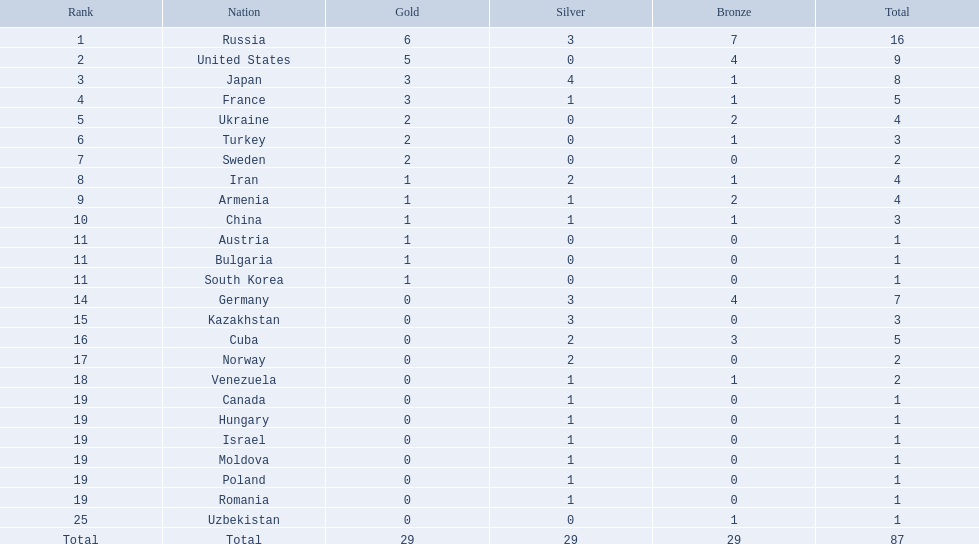Which nations participated in the championships? Russia, United States, Japan, France, Ukraine, Turkey, Sweden, Iran, Armenia, China, Austria, Bulgaria, South Korea, Germany, Kazakhstan, Cuba, Norway, Venezuela, Canada, Hungary, Israel, Moldova, Poland, Romania, Uzbekistan. How many bronze medals did they receive? 7, 4, 1, 1, 2, 1, 0, 1, 2, 1, 0, 0, 0, 4, 0, 3, 0, 1, 0, 0, 0, 0, 0, 0, 1, 29. How many in total? 16, 9, 8, 5, 4, 3, 2, 4, 4, 3, 1, 1, 1, 7, 3, 5, 2, 2, 1, 1, 1, 1, 1, 1, 1. And which team won only one medal -- the bronze? Uzbekistan. Which states achieved under 5 medals? Ukraine, Turkey, Sweden, Iran, Armenia, China, Austria, Bulgaria, South Korea, Germany, Kazakhstan, Norway, Venezuela, Canada, Hungary, Israel, Moldova, Poland, Romania, Uzbekistan. Which of these were not eastern nations? Ukraine, Turkey, Sweden, Iran, Armenia, Austria, Bulgaria, Germany, Kazakhstan, Norway, Venezuela, Canada, Hungary, Israel, Moldova, Poland, Romania, Uzbekistan. Which of those did not earn any silver medals? Ukraine, Turkey, Sweden, Austria, Bulgaria, Uzbekistan. Which ones of these had solely one medal in total? Austria, Bulgaria, Uzbekistan. Which of those would be ordered first alphabetically? Austria. What was the ranking of iran? 8. What was the ranking of germany? 14. Which country among them was part of the top 10 rank? Germany. What countries exist? Russia, 6, United States, 5, Japan, 3, France, 3, Ukraine, 2, Turkey, 2, Sweden, 2, Iran, 1, Armenia, 1, China, 1, Austria, 1, Bulgaria, 1, South Korea, 1, Germany, 0, Kazakhstan, 0, Cuba, 0, Norway, 0, Venezuela, 0, Canada, 0, Hungary, 0, Israel, 0, Moldova, 0, Poland, 0, Romania, 0, Uzbekistan, 0. Which of these countries have won gold? Russia, 6, United States, 5, Japan, 3, France, 3, Ukraine, 2, Turkey, 2, Sweden, 2, Iran, 1, Armenia, 1, China, 1, Austria, 1, Bulgaria, 1, South Korea, 1. What is the total number of gold medals won by the united states? United States, 5. Which country has a gold medal count exceeding 5? Russia, 6. What is the name of this country? Russia. What was the total count of countries that took part? Israel. How many medals were acquired by russia? 16. Which country had a single medal victory? Uzbekistan. Which nations have exactly one gold medal to their name? Iran, Armenia, China, Austria, Bulgaria, South Korea. From this group, which ones have not won any silver medals? Austria, Bulgaria, South Korea. Moreover, which of these nations have not secured any bronze medals either? Austria. 